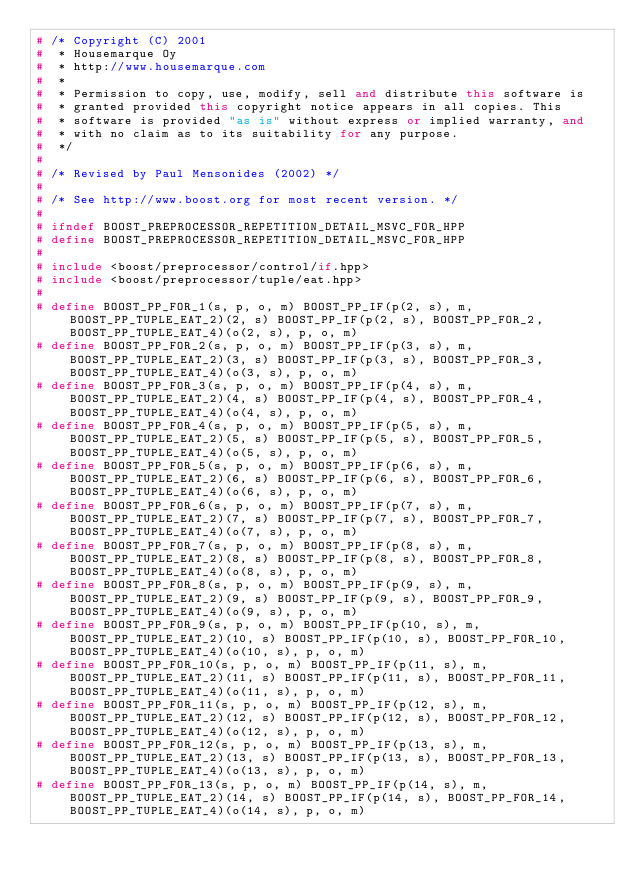Convert code to text. <code><loc_0><loc_0><loc_500><loc_500><_C++_># /* Copyright (C) 2001
#  * Housemarque Oy
#  * http://www.housemarque.com
#  *
#  * Permission to copy, use, modify, sell and distribute this software is
#  * granted provided this copyright notice appears in all copies. This
#  * software is provided "as is" without express or implied warranty, and
#  * with no claim as to its suitability for any purpose.
#  */
#
# /* Revised by Paul Mensonides (2002) */
#
# /* See http://www.boost.org for most recent version. */
#
# ifndef BOOST_PREPROCESSOR_REPETITION_DETAIL_MSVC_FOR_HPP
# define BOOST_PREPROCESSOR_REPETITION_DETAIL_MSVC_FOR_HPP
#
# include <boost/preprocessor/control/if.hpp>
# include <boost/preprocessor/tuple/eat.hpp>
#
# define BOOST_PP_FOR_1(s, p, o, m) BOOST_PP_IF(p(2, s), m, BOOST_PP_TUPLE_EAT_2)(2, s) BOOST_PP_IF(p(2, s), BOOST_PP_FOR_2, BOOST_PP_TUPLE_EAT_4)(o(2, s), p, o, m)
# define BOOST_PP_FOR_2(s, p, o, m) BOOST_PP_IF(p(3, s), m, BOOST_PP_TUPLE_EAT_2)(3, s) BOOST_PP_IF(p(3, s), BOOST_PP_FOR_3, BOOST_PP_TUPLE_EAT_4)(o(3, s), p, o, m)
# define BOOST_PP_FOR_3(s, p, o, m) BOOST_PP_IF(p(4, s), m, BOOST_PP_TUPLE_EAT_2)(4, s) BOOST_PP_IF(p(4, s), BOOST_PP_FOR_4, BOOST_PP_TUPLE_EAT_4)(o(4, s), p, o, m)
# define BOOST_PP_FOR_4(s, p, o, m) BOOST_PP_IF(p(5, s), m, BOOST_PP_TUPLE_EAT_2)(5, s) BOOST_PP_IF(p(5, s), BOOST_PP_FOR_5, BOOST_PP_TUPLE_EAT_4)(o(5, s), p, o, m)
# define BOOST_PP_FOR_5(s, p, o, m) BOOST_PP_IF(p(6, s), m, BOOST_PP_TUPLE_EAT_2)(6, s) BOOST_PP_IF(p(6, s), BOOST_PP_FOR_6, BOOST_PP_TUPLE_EAT_4)(o(6, s), p, o, m)
# define BOOST_PP_FOR_6(s, p, o, m) BOOST_PP_IF(p(7, s), m, BOOST_PP_TUPLE_EAT_2)(7, s) BOOST_PP_IF(p(7, s), BOOST_PP_FOR_7, BOOST_PP_TUPLE_EAT_4)(o(7, s), p, o, m)
# define BOOST_PP_FOR_7(s, p, o, m) BOOST_PP_IF(p(8, s), m, BOOST_PP_TUPLE_EAT_2)(8, s) BOOST_PP_IF(p(8, s), BOOST_PP_FOR_8, BOOST_PP_TUPLE_EAT_4)(o(8, s), p, o, m)
# define BOOST_PP_FOR_8(s, p, o, m) BOOST_PP_IF(p(9, s), m, BOOST_PP_TUPLE_EAT_2)(9, s) BOOST_PP_IF(p(9, s), BOOST_PP_FOR_9, BOOST_PP_TUPLE_EAT_4)(o(9, s), p, o, m)
# define BOOST_PP_FOR_9(s, p, o, m) BOOST_PP_IF(p(10, s), m, BOOST_PP_TUPLE_EAT_2)(10, s) BOOST_PP_IF(p(10, s), BOOST_PP_FOR_10, BOOST_PP_TUPLE_EAT_4)(o(10, s), p, o, m)
# define BOOST_PP_FOR_10(s, p, o, m) BOOST_PP_IF(p(11, s), m, BOOST_PP_TUPLE_EAT_2)(11, s) BOOST_PP_IF(p(11, s), BOOST_PP_FOR_11, BOOST_PP_TUPLE_EAT_4)(o(11, s), p, o, m)
# define BOOST_PP_FOR_11(s, p, o, m) BOOST_PP_IF(p(12, s), m, BOOST_PP_TUPLE_EAT_2)(12, s) BOOST_PP_IF(p(12, s), BOOST_PP_FOR_12, BOOST_PP_TUPLE_EAT_4)(o(12, s), p, o, m)
# define BOOST_PP_FOR_12(s, p, o, m) BOOST_PP_IF(p(13, s), m, BOOST_PP_TUPLE_EAT_2)(13, s) BOOST_PP_IF(p(13, s), BOOST_PP_FOR_13, BOOST_PP_TUPLE_EAT_4)(o(13, s), p, o, m)
# define BOOST_PP_FOR_13(s, p, o, m) BOOST_PP_IF(p(14, s), m, BOOST_PP_TUPLE_EAT_2)(14, s) BOOST_PP_IF(p(14, s), BOOST_PP_FOR_14, BOOST_PP_TUPLE_EAT_4)(o(14, s), p, o, m)</code> 